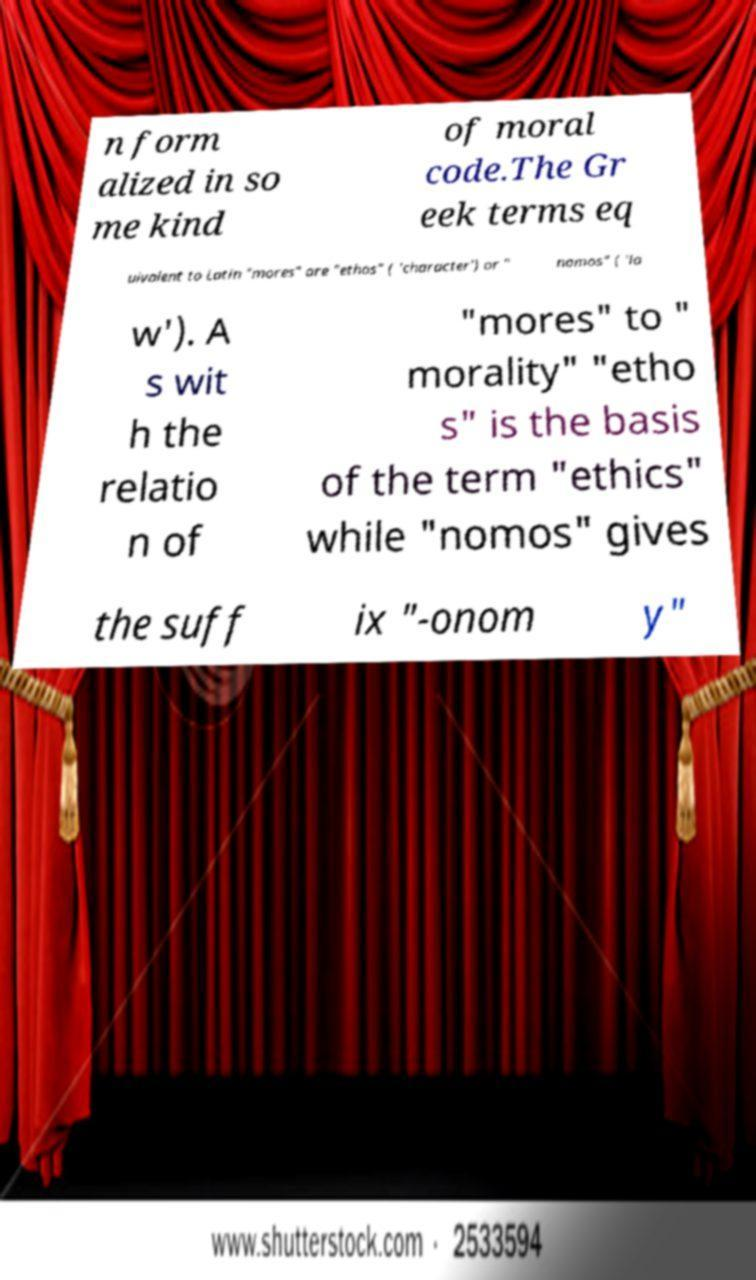Can you accurately transcribe the text from the provided image for me? n form alized in so me kind of moral code.The Gr eek terms eq uivalent to Latin "mores" are "ethos" ( 'character') or " nomos" ( 'la w'). A s wit h the relatio n of "mores" to " morality" "etho s" is the basis of the term "ethics" while "nomos" gives the suff ix "-onom y" 